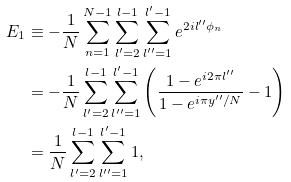<formula> <loc_0><loc_0><loc_500><loc_500>E _ { 1 } & \equiv - \frac { 1 } { N } \sum _ { n = 1 } ^ { N - 1 } \sum _ { l ^ { \prime } = 2 } ^ { l - 1 } \sum _ { l ^ { \prime \prime } = 1 } ^ { l ^ { \prime } - 1 } e ^ { 2 i l ^ { \prime \prime } \phi _ { n } } \\ & = - \frac { 1 } { N } \sum _ { l ^ { \prime } = 2 } ^ { l - 1 } \sum _ { l ^ { \prime \prime } = 1 } ^ { l ^ { \prime } - 1 } \left ( \frac { 1 - e ^ { i 2 \pi l ^ { \prime \prime } } } { 1 - e ^ { i \pi y ^ { \prime \prime } / N } } - 1 \right ) \\ & = \frac { 1 } { N } \sum _ { l ^ { \prime } = 2 } ^ { l - 1 } \sum _ { l ^ { \prime \prime } = 1 } ^ { l ^ { \prime } - 1 } 1 ,</formula> 